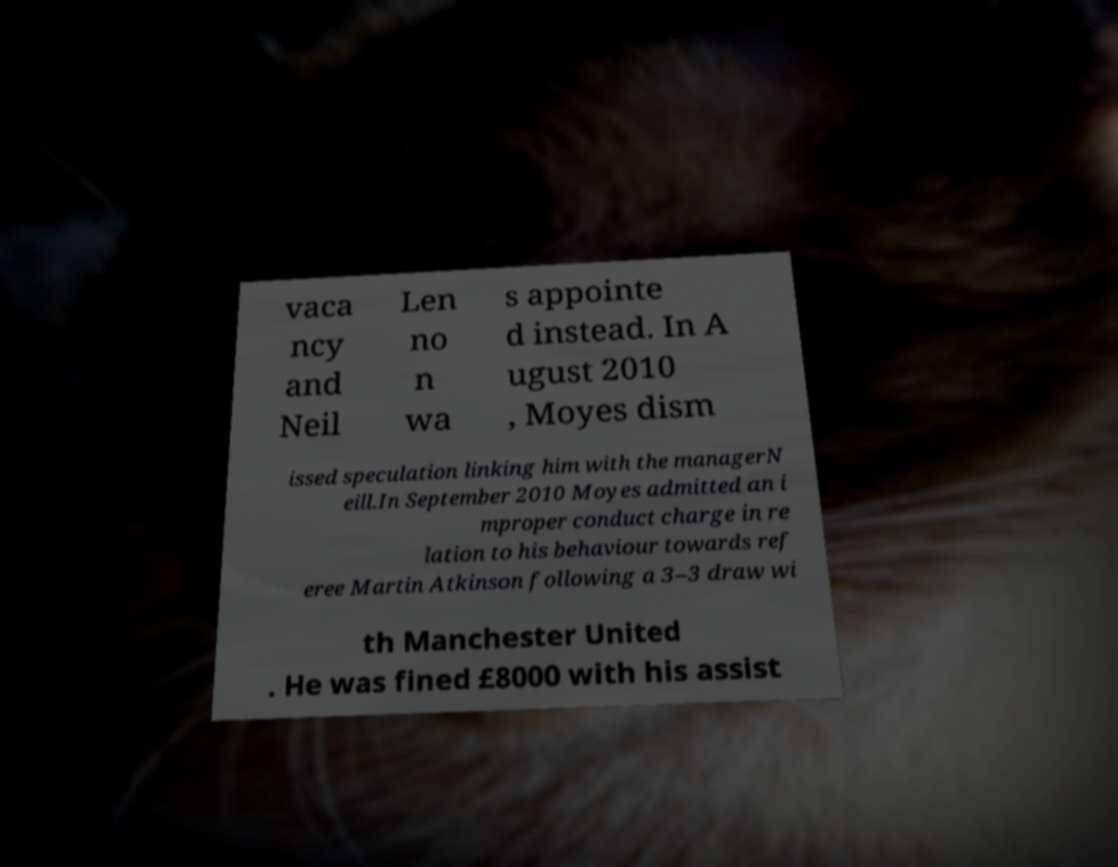Please identify and transcribe the text found in this image. vaca ncy and Neil Len no n wa s appointe d instead. In A ugust 2010 , Moyes dism issed speculation linking him with the managerN eill.In September 2010 Moyes admitted an i mproper conduct charge in re lation to his behaviour towards ref eree Martin Atkinson following a 3–3 draw wi th Manchester United . He was fined £8000 with his assist 